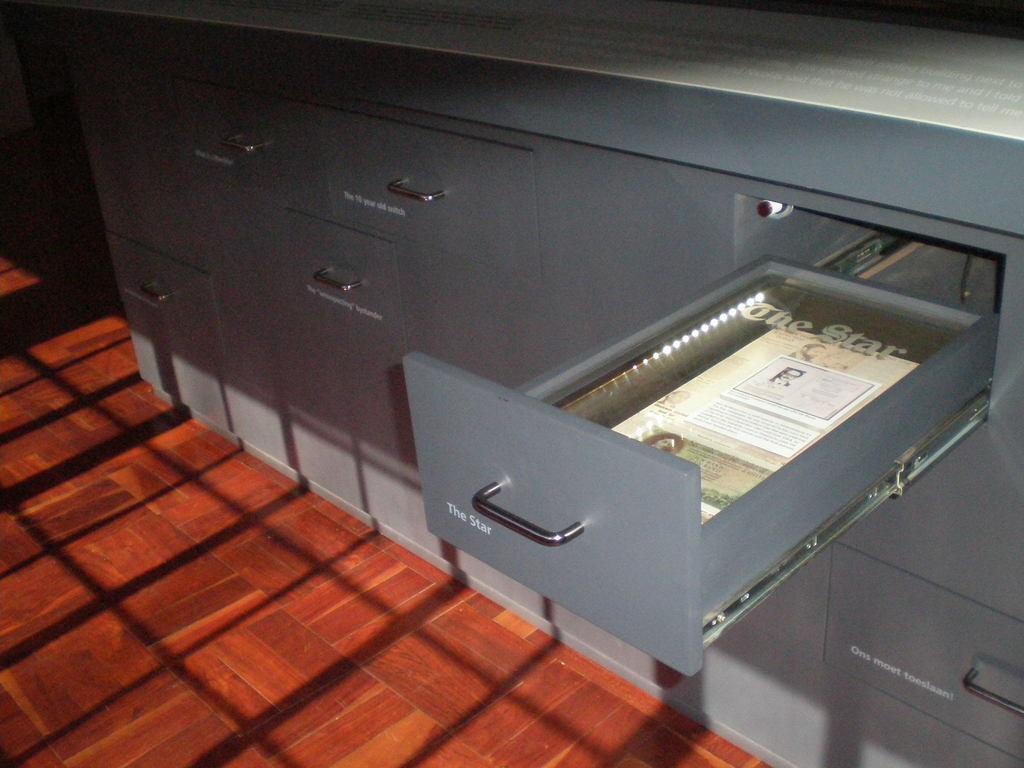How would you summarize this image in a sentence or two? This picture shows a table with drawers and we see a draw opened and we see papers in it. 